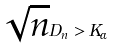Convert formula to latex. <formula><loc_0><loc_0><loc_500><loc_500>\sqrt { n } D _ { n } > K _ { \alpha }</formula> 